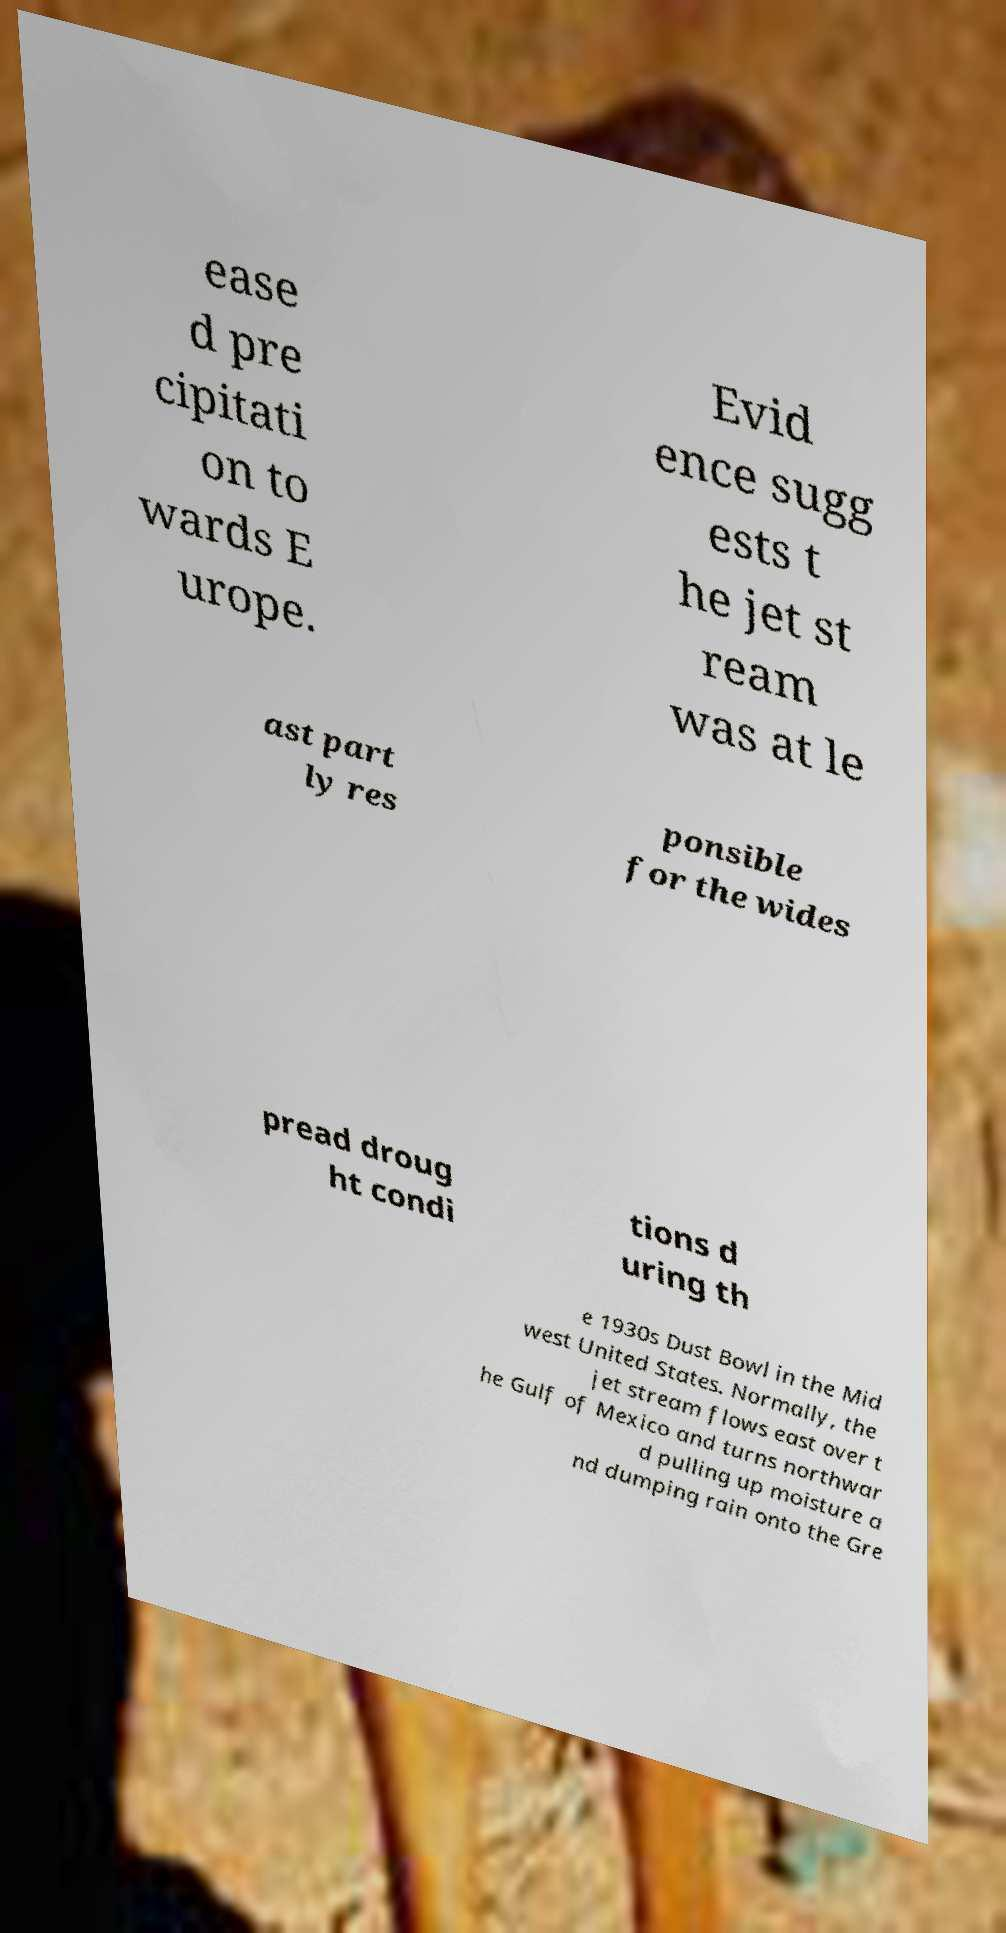There's text embedded in this image that I need extracted. Can you transcribe it verbatim? ease d pre cipitati on to wards E urope. Evid ence sugg ests t he jet st ream was at le ast part ly res ponsible for the wides pread droug ht condi tions d uring th e 1930s Dust Bowl in the Mid west United States. Normally, the jet stream flows east over t he Gulf of Mexico and turns northwar d pulling up moisture a nd dumping rain onto the Gre 